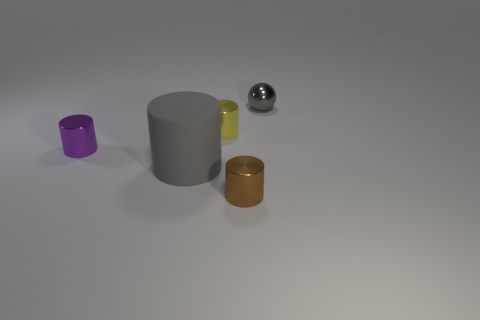How many things are either tiny metallic things on the left side of the big gray thing or brown spheres?
Ensure brevity in your answer.  1. What shape is the small metallic object in front of the gray thing on the left side of the small yellow metal object?
Offer a very short reply. Cylinder. Is there a yellow thing of the same size as the brown thing?
Your response must be concise. Yes. Are there more small metallic things than things?
Keep it short and to the point. No. There is a metallic cylinder in front of the big gray matte thing; is it the same size as the gray object that is behind the big gray thing?
Provide a succinct answer. Yes. How many shiny things are both in front of the tiny yellow cylinder and on the right side of the tiny purple metallic object?
Ensure brevity in your answer.  1. What color is the other rubber object that is the same shape as the tiny purple object?
Give a very brief answer. Gray. Is the number of balls less than the number of big blocks?
Provide a succinct answer. No. Does the yellow shiny cylinder have the same size as the gray rubber thing left of the small brown thing?
Your response must be concise. No. There is a thing in front of the gray thing in front of the small purple metal cylinder; what color is it?
Ensure brevity in your answer.  Brown. 